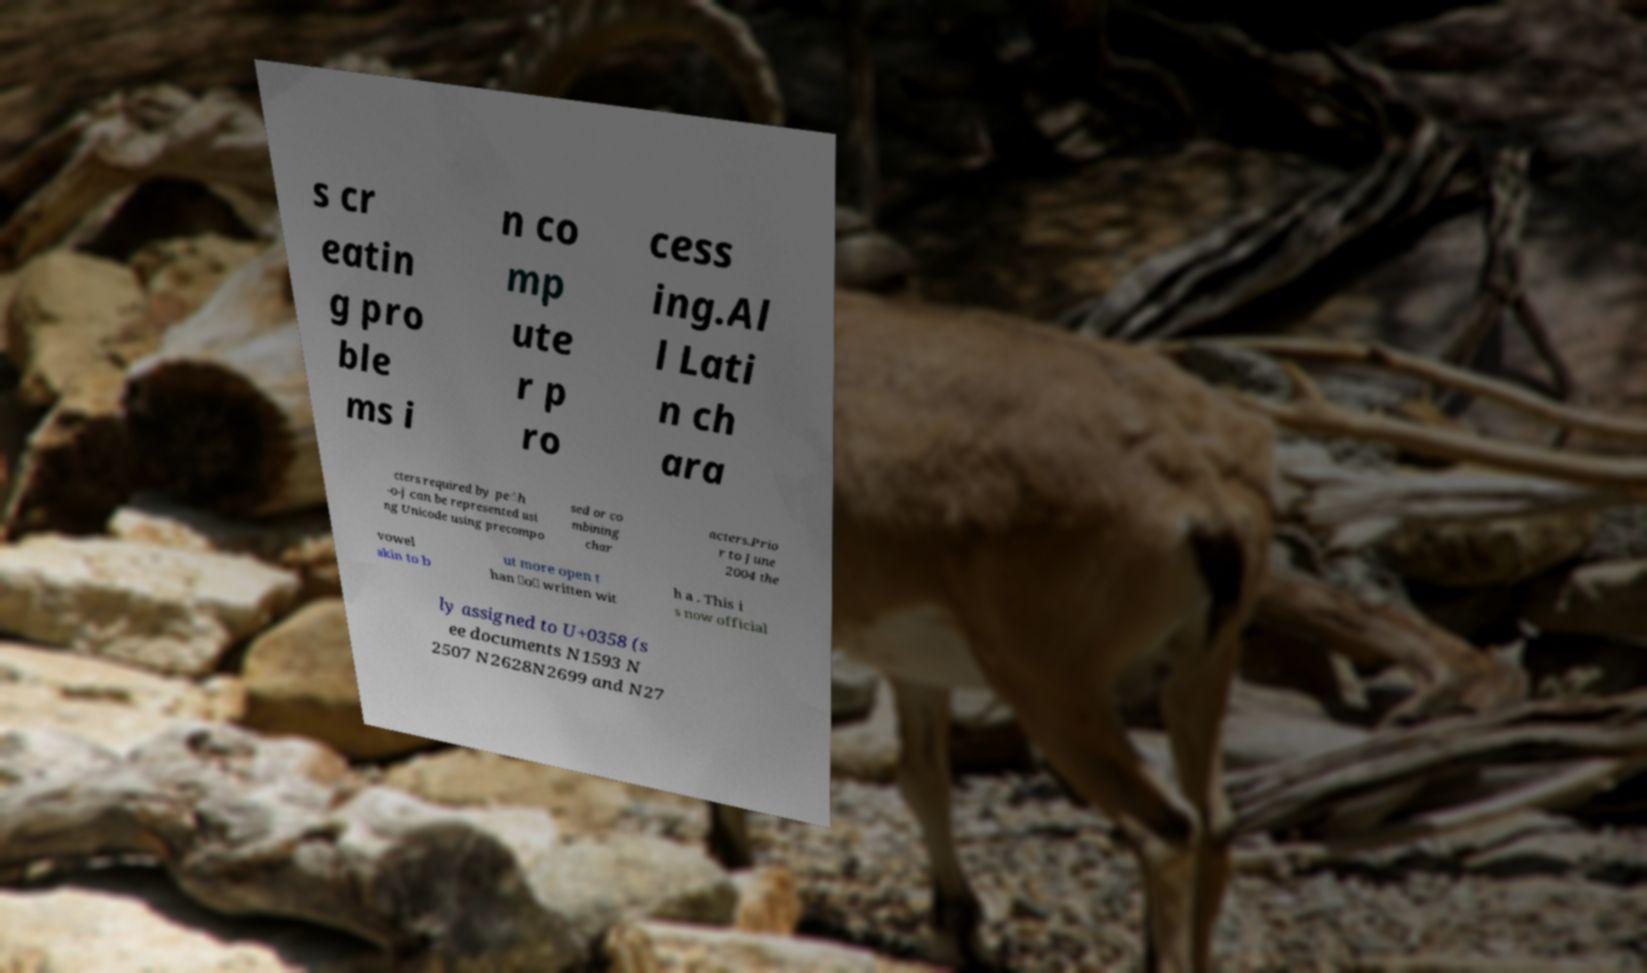Can you accurately transcribe the text from the provided image for me? s cr eatin g pro ble ms i n co mp ute r p ro cess ing.Al l Lati n ch ara cters required by pe̍h -o-j can be represented usi ng Unicode using precompo sed or co mbining char acters.Prio r to June 2004 the vowel akin to b ut more open t han ⟨o⟩ written wit h a . This i s now official ly assigned to U+0358 (s ee documents N1593 N 2507 N2628N2699 and N27 